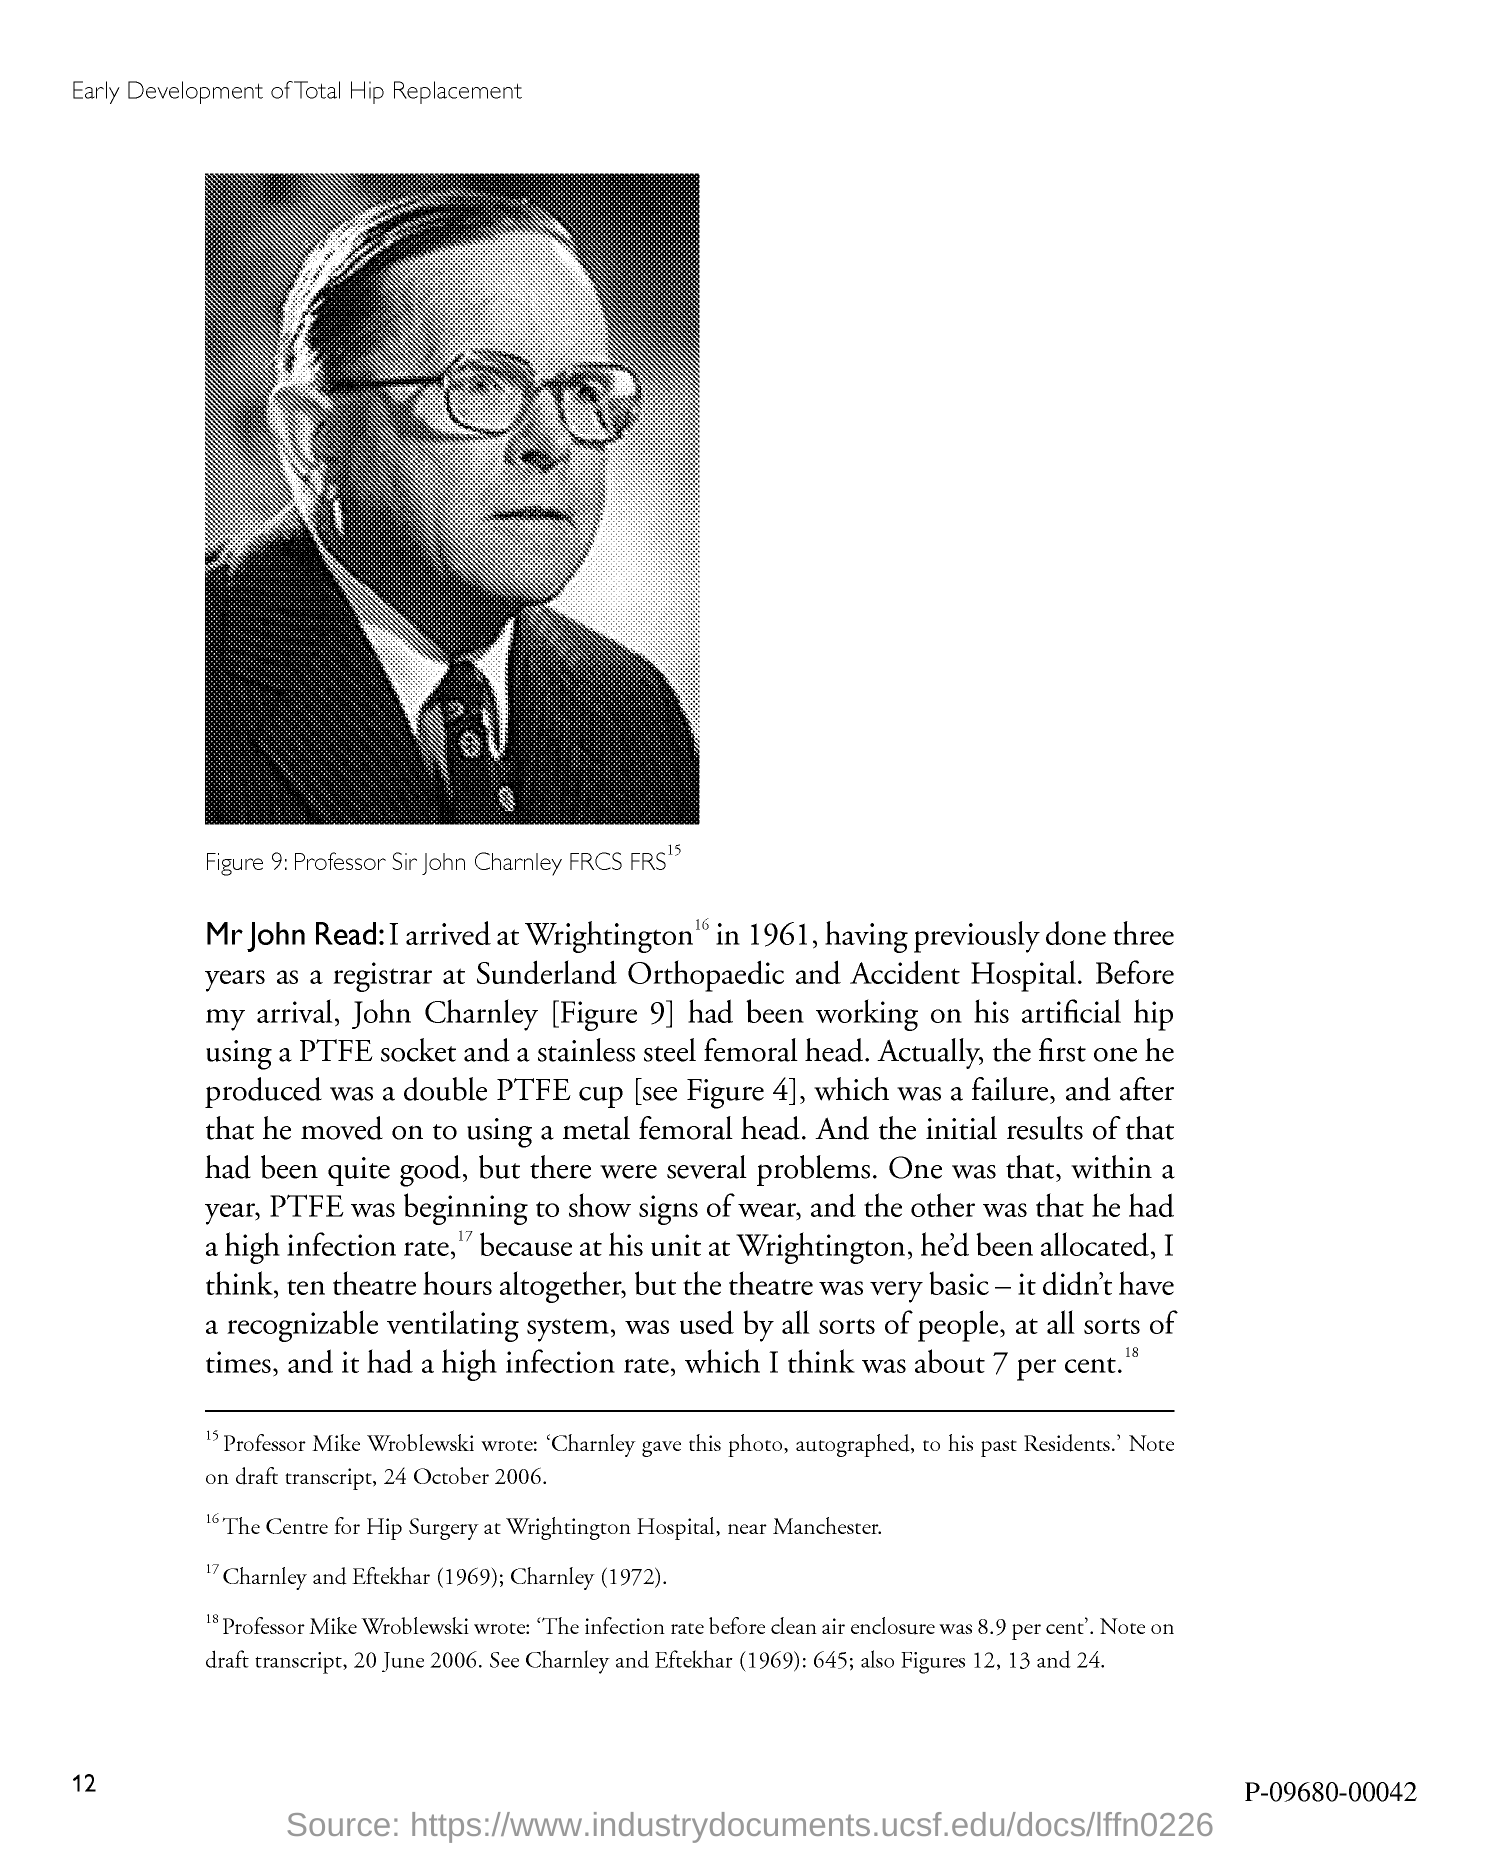Point out several critical features in this image. The image shown in Figure 9 belongs to Professor Sir John Charnley FRCS FRS. 